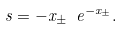Convert formula to latex. <formula><loc_0><loc_0><loc_500><loc_500>s = - x _ { \pm } \ e ^ { - x _ { \pm } } .</formula> 